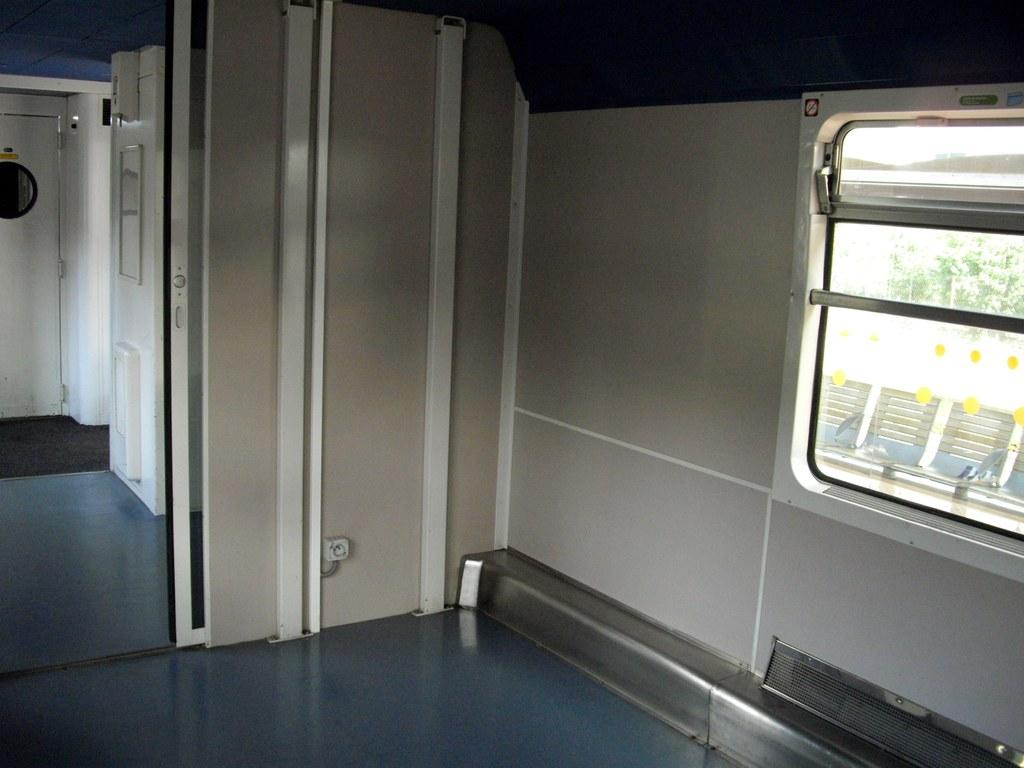What is the main subject of the image? The image shows the internal structure of a vehicle. Can you identify any specific features of the vehicle? Yes, there is a window visible in the vehicle. What can be seen through the window? Leaves are visible through the window. What color is the parcel sitting on the dashboard in the image? There is no parcel present in the image. What type of wire can be seen connecting the dashboard to the steering wheel in the image? There is no wire connecting the dashboard to the steering wheel in the image. 